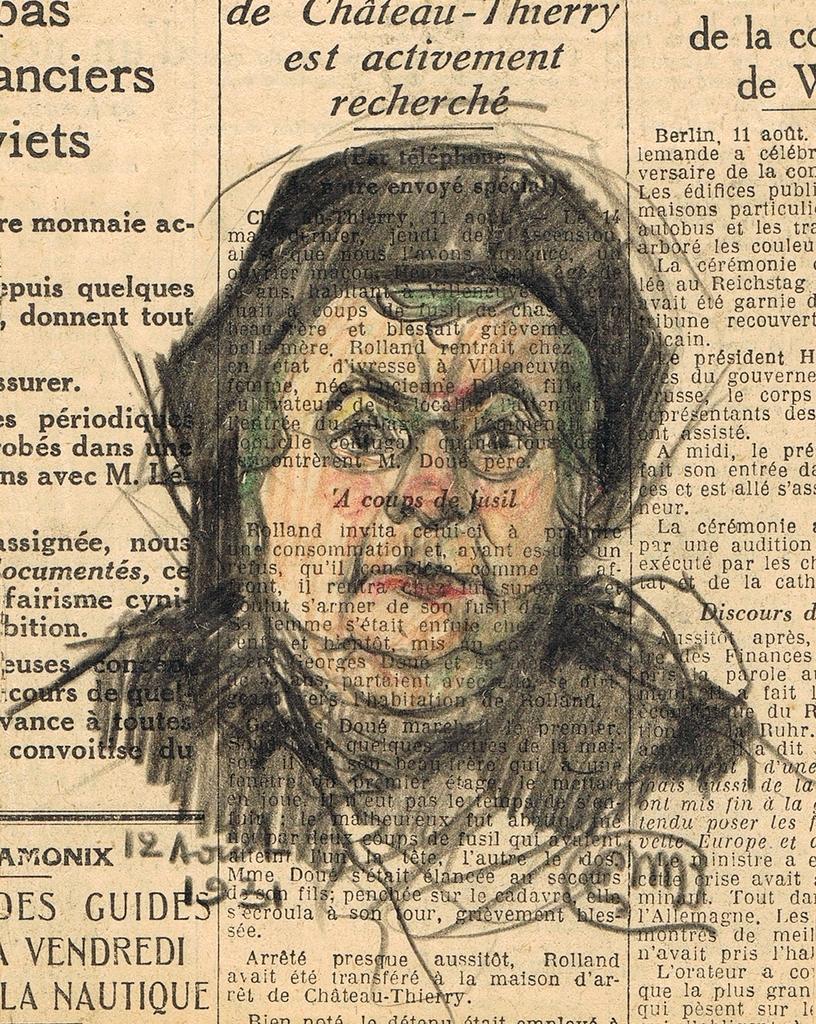Can you describe this image briefly? There is a sketch of a person on the news paper, on which there are black color texts. 